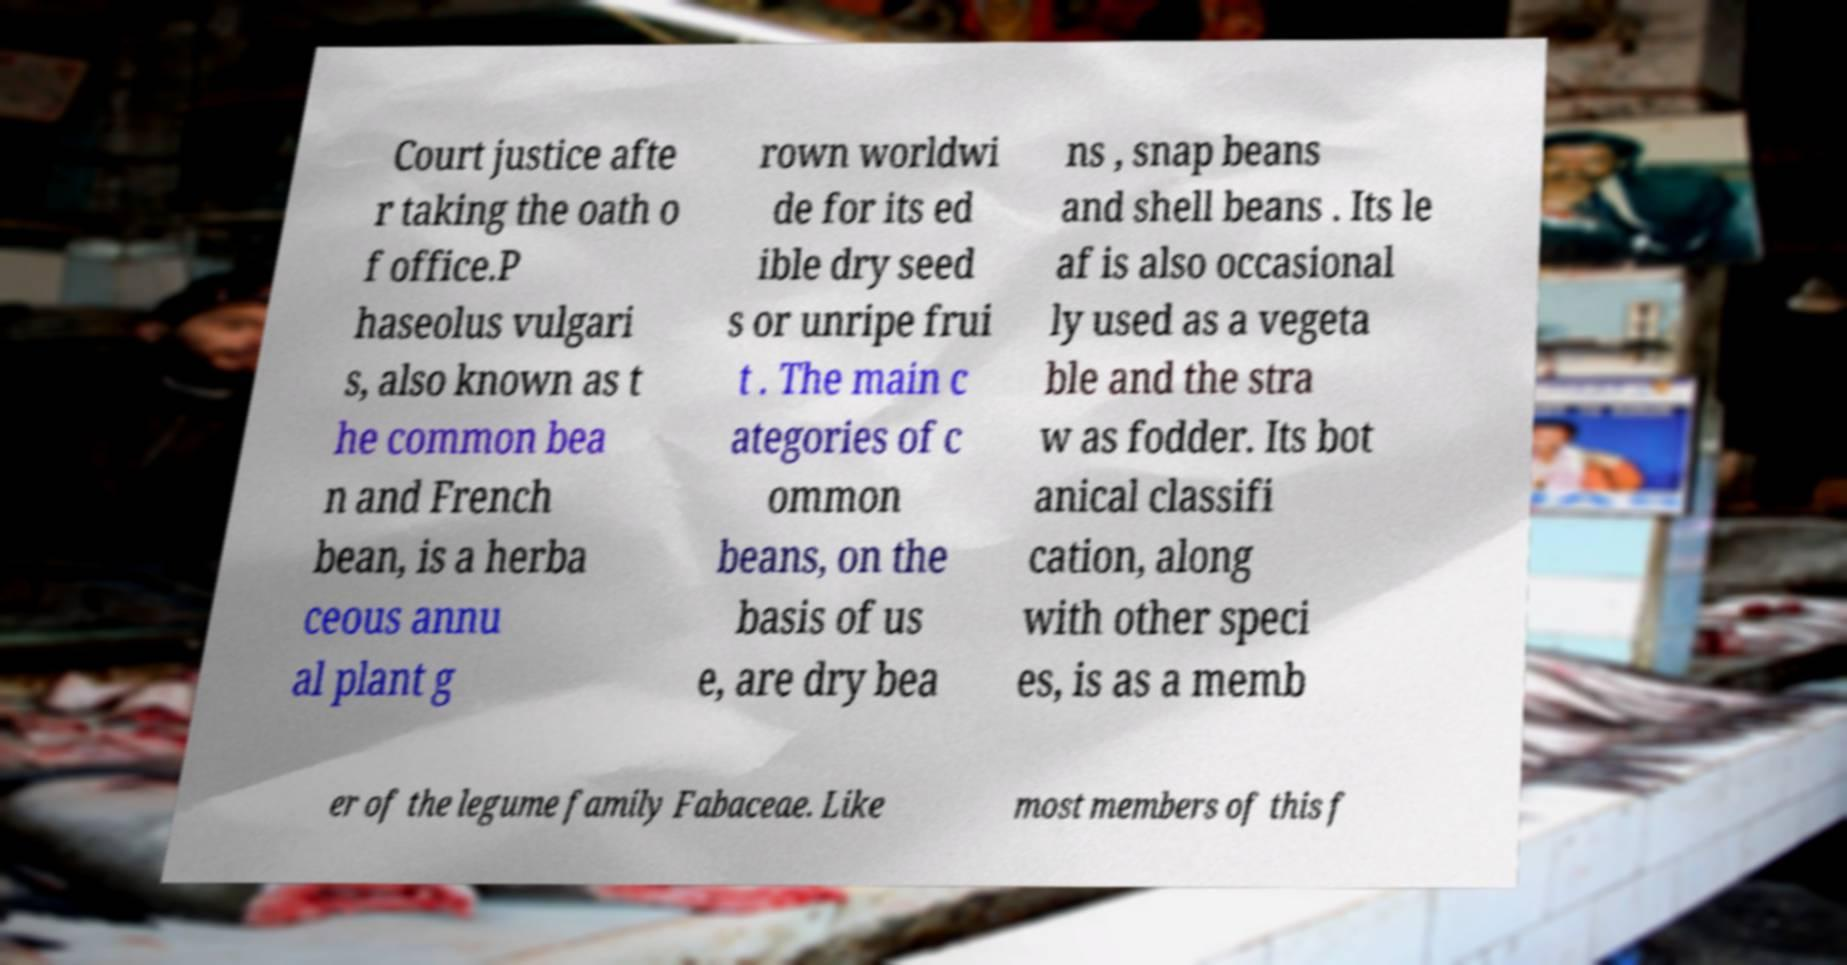Could you assist in decoding the text presented in this image and type it out clearly? Court justice afte r taking the oath o f office.P haseolus vulgari s, also known as t he common bea n and French bean, is a herba ceous annu al plant g rown worldwi de for its ed ible dry seed s or unripe frui t . The main c ategories of c ommon beans, on the basis of us e, are dry bea ns , snap beans and shell beans . Its le af is also occasional ly used as a vegeta ble and the stra w as fodder. Its bot anical classifi cation, along with other speci es, is as a memb er of the legume family Fabaceae. Like most members of this f 